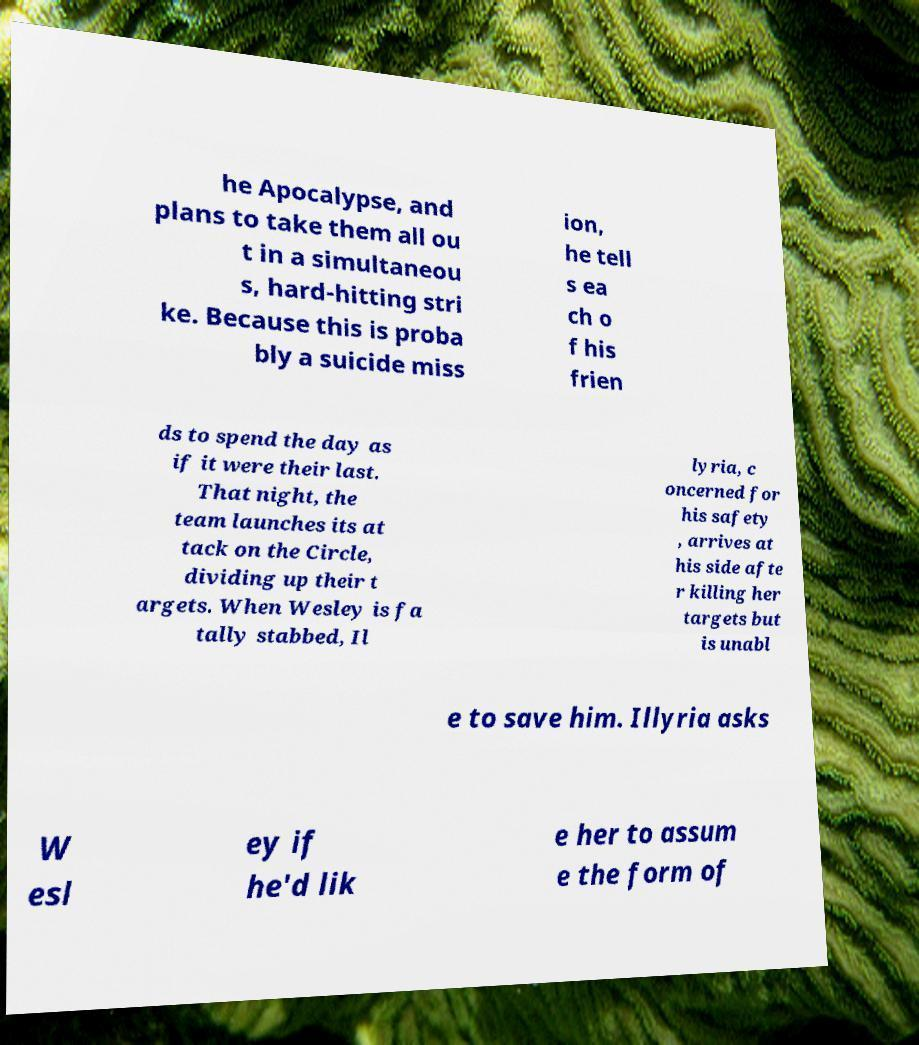Please read and relay the text visible in this image. What does it say? he Apocalypse, and plans to take them all ou t in a simultaneou s, hard-hitting stri ke. Because this is proba bly a suicide miss ion, he tell s ea ch o f his frien ds to spend the day as if it were their last. That night, the team launches its at tack on the Circle, dividing up their t argets. When Wesley is fa tally stabbed, Il lyria, c oncerned for his safety , arrives at his side afte r killing her targets but is unabl e to save him. Illyria asks W esl ey if he'd lik e her to assum e the form of 